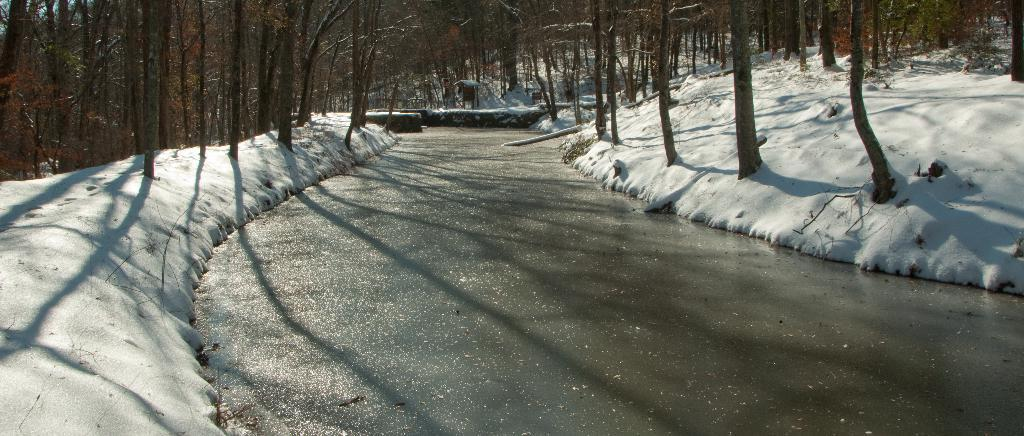What is the main feature of the image? There is a road in the image. What is the condition of the environment surrounding the road? Snow is present on both sides of the road. What can be seen in the distance in the image? Trees are visible in the background of the image. Can you describe the wooden object in the background? There is a wooden object in the background of the image. How many mice are hiding under the wooden object in the image? There are no mice present in the image, and therefore no mice can be hiding under the wooden object. What type of veil is draped over the trees in the background? There is no veil present in the image; the trees are visible without any covering. 